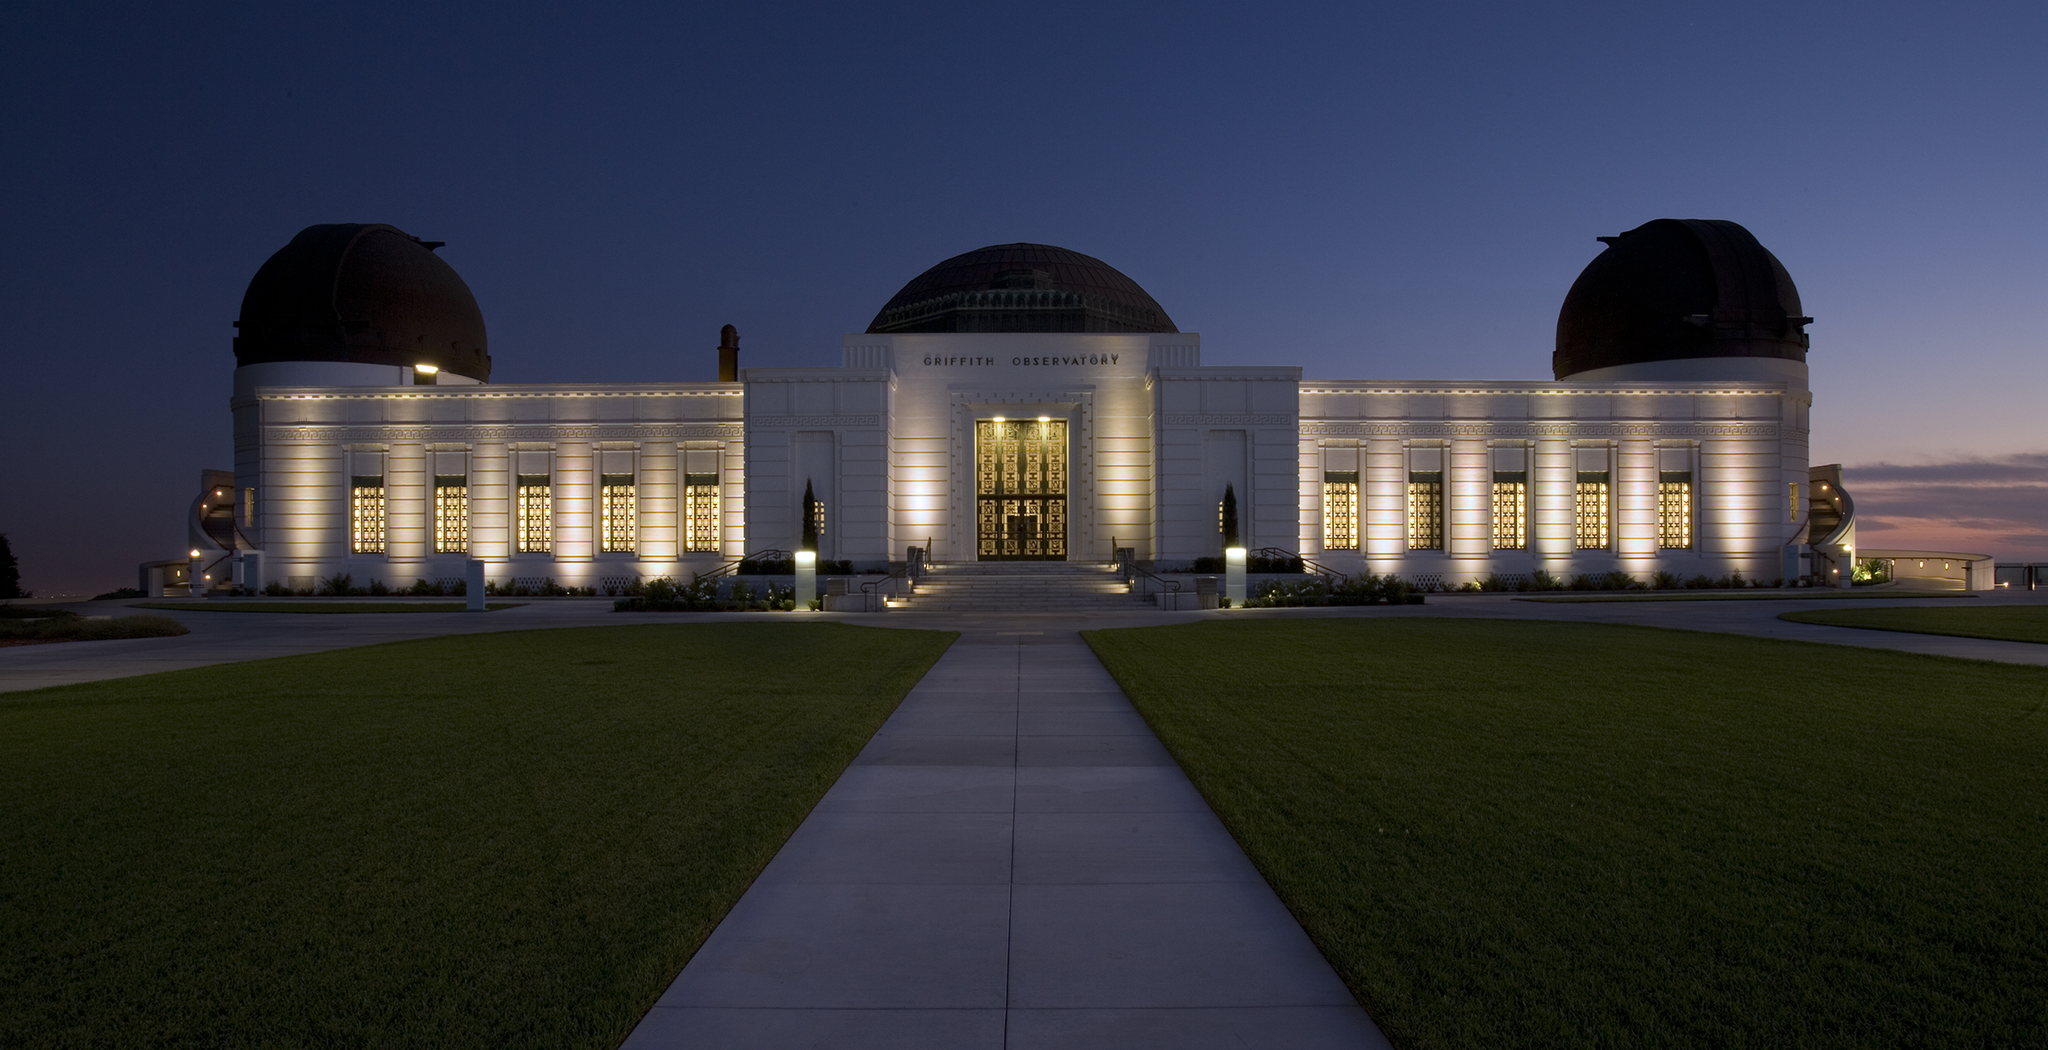Imagine a fictional event taking place at this observatory. Imagine an interstellar science fair taking place at the Griffith Observatory. The whole area is transformed into a cosmic playground, with displays ranging from meteorite fragments to interactive holograms of distant galaxies. Alien-themed decorations add a whimsical touch, and visitors are handed 'space passports' that get stamped at different exhibits. Astronomers and scientists from around the world attend to share the latest discoveries in space exploration. A special nighttime event has telescopes set up for a rare planetary alignment, and attendees can participate in a live stream with an astronaut aboard the International Space Station. The observatory, lit with vibrant colors and buzzing with excitement, becomes a portal that sparks the imagination, encouraging everyone to look up and wonder what lies beyond our blue sky. 